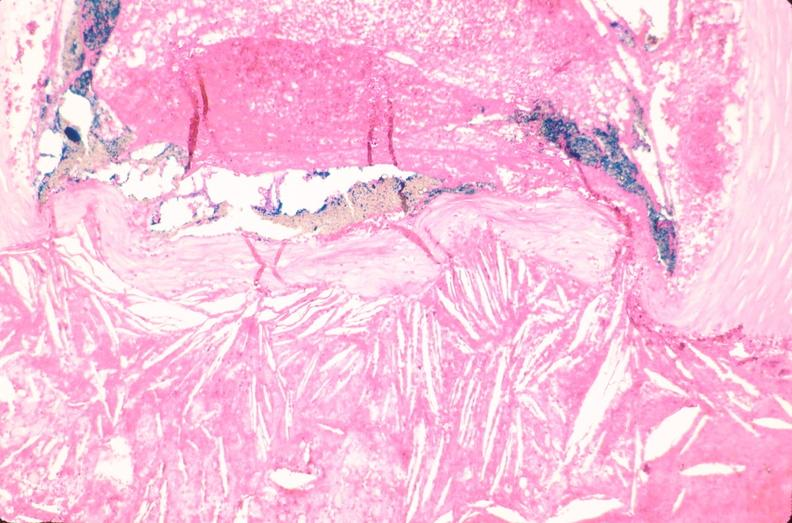s intraductal papillomatosis present?
Answer the question using a single word or phrase. No 